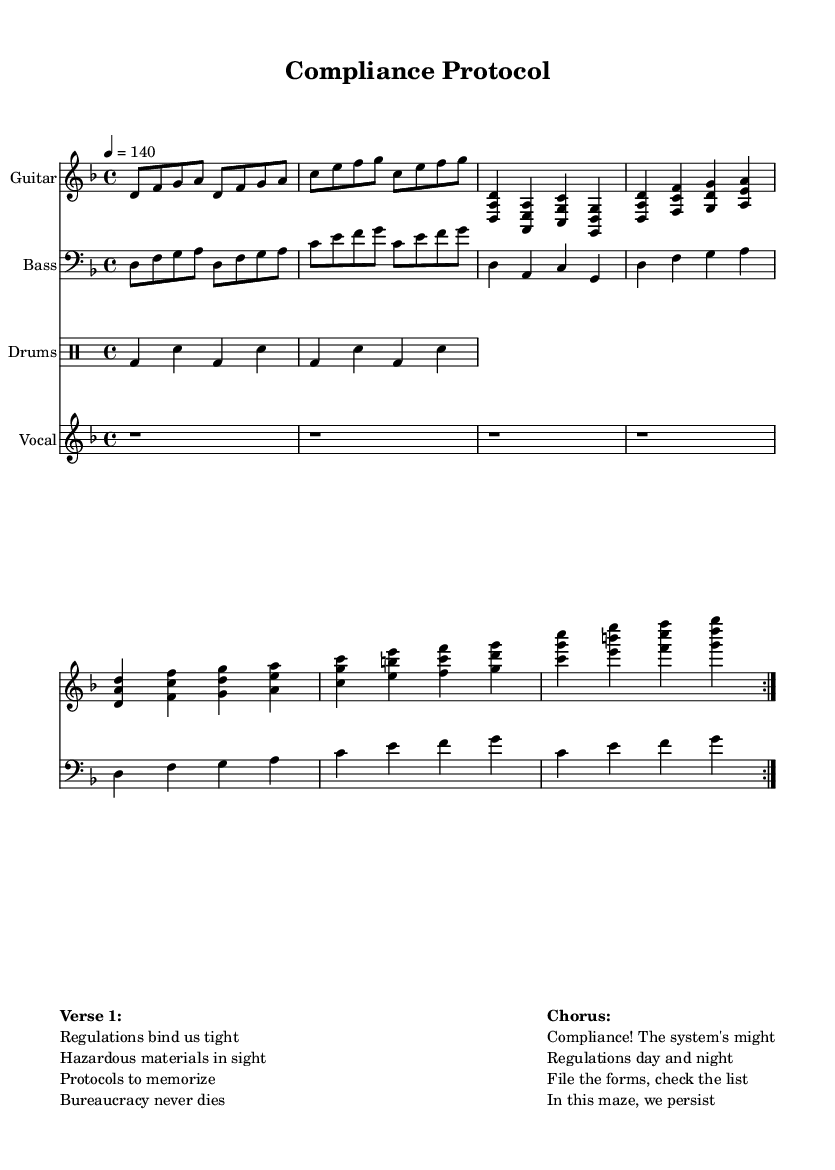What is the key signature of this music? The key signature is D minor, which contains one flat (B flat). This is indicated at the beginning of the score.
Answer: D minor What is the time signature of this music? The time signature is 4/4, which means there are four beats in a measure and a quarter note gets one beat. This is clearly notated at the beginning of the score.
Answer: 4/4 What is the tempo marking of the music? The tempo marking is 4 = 140, signifying that the quarter note should be played at 140 beats per minute. The tempo is found in the global section of the score.
Answer: 140 Which section directly follows the "guitarVerse"? The section that follows "guitarVerse" is "guitarChorus" as indicated by the structure laid out in the score under the Guitar staff.
Answer: guitarChorus How many times is the "guitarRiff" repeated? The "guitarRiff" is repeated twice, as indicated by the repeat markings (volta) before the verses and choruses in the Guitar staff.
Answer: 2 What do the lyrics of the chorus emphasize in relation to government regulations? The lyrics of the chorus emphasize the importance and omnipresence of compliance with regulations ("Compliance! The system's might"). This reflects the theme of the song regarding bureaucracy.
Answer: Compliance What instrument is the vocal part aligned with in the score? The vocal part is aligned with the guitar part which has similar structural sections, enhancing the synergy between the lyrics and the guitar riff. This can be seen by examining the layout of all parts in the score.
Answer: Guitar 